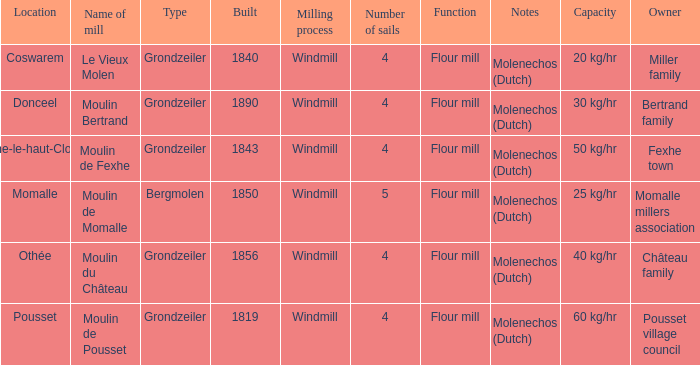What is the Name of the Grondzeiler Mill? Le Vieux Molen, Moulin Bertrand, Moulin de Fexhe, Moulin du Château, Moulin de Pousset. 